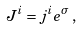Convert formula to latex. <formula><loc_0><loc_0><loc_500><loc_500>J ^ { i } = j ^ { i } e ^ { \sigma } \, ,</formula> 